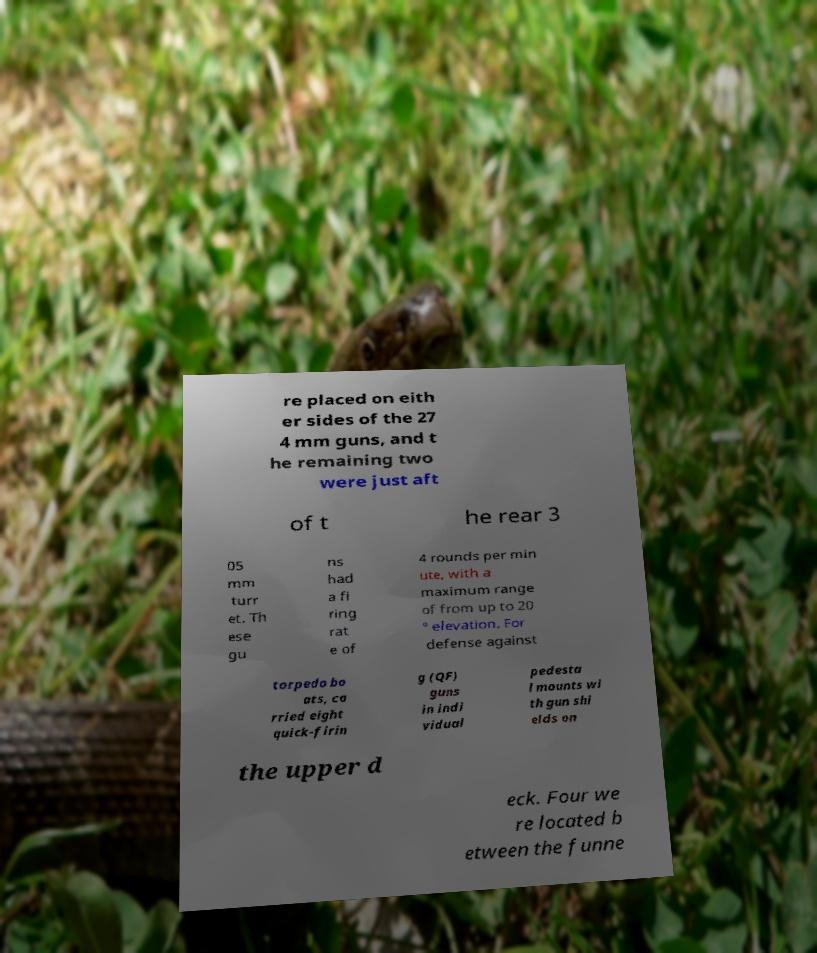Please identify and transcribe the text found in this image. re placed on eith er sides of the 27 4 mm guns, and t he remaining two were just aft of t he rear 3 05 mm turr et. Th ese gu ns had a fi ring rat e of 4 rounds per min ute, with a maximum range of from up to 20 ° elevation. For defense against torpedo bo ats, ca rried eight quick-firin g (QF) guns in indi vidual pedesta l mounts wi th gun shi elds on the upper d eck. Four we re located b etween the funne 